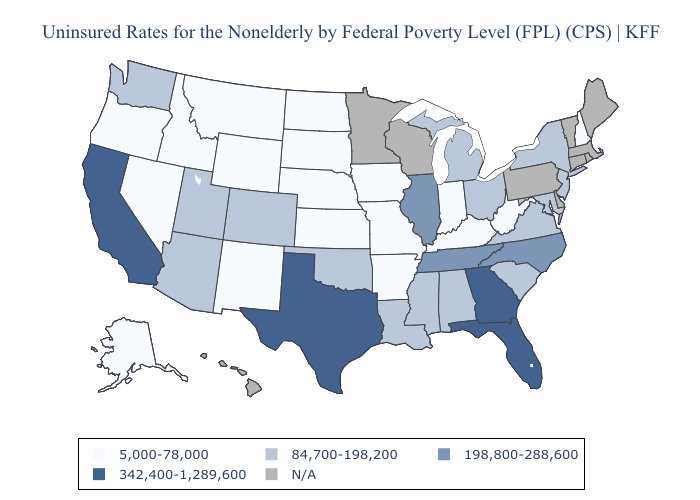What is the value of Indiana?
Concise answer only. 5,000-78,000. Name the states that have a value in the range 198,800-288,600?
Concise answer only. Illinois, North Carolina, Tennessee. What is the highest value in the West ?
Answer briefly. 342,400-1,289,600. Name the states that have a value in the range 342,400-1,289,600?
Concise answer only. California, Florida, Georgia, Texas. Name the states that have a value in the range 342,400-1,289,600?
Quick response, please. California, Florida, Georgia, Texas. Does New Hampshire have the lowest value in the Northeast?
Keep it brief. Yes. What is the value of New York?
Keep it brief. 84,700-198,200. Among the states that border Idaho , does Washington have the lowest value?
Keep it brief. No. What is the value of Indiana?
Give a very brief answer. 5,000-78,000. Does Mississippi have the lowest value in the USA?
Answer briefly. No. Name the states that have a value in the range 198,800-288,600?
Give a very brief answer. Illinois, North Carolina, Tennessee. Among the states that border South Carolina , does Georgia have the lowest value?
Give a very brief answer. No. What is the highest value in the USA?
Short answer required. 342,400-1,289,600. What is the value of Alabama?
Be succinct. 84,700-198,200. Among the states that border New Mexico , which have the lowest value?
Quick response, please. Arizona, Colorado, Oklahoma, Utah. 